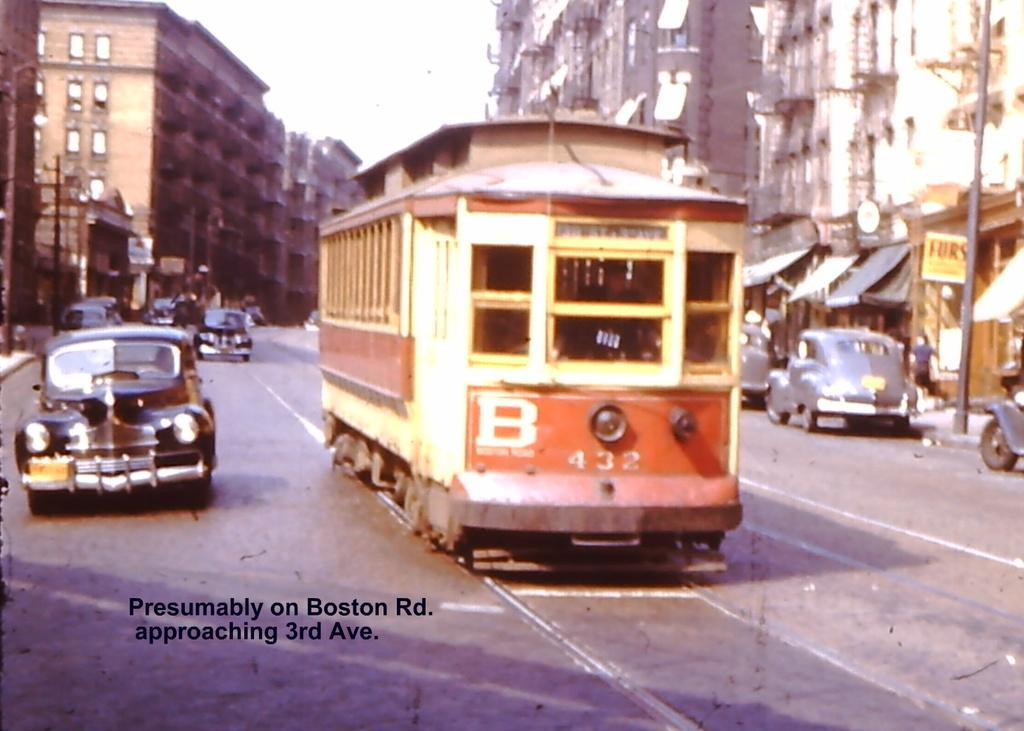<image>
Relay a brief, clear account of the picture shown. Bus with the numbers 432 on it going down a road. 